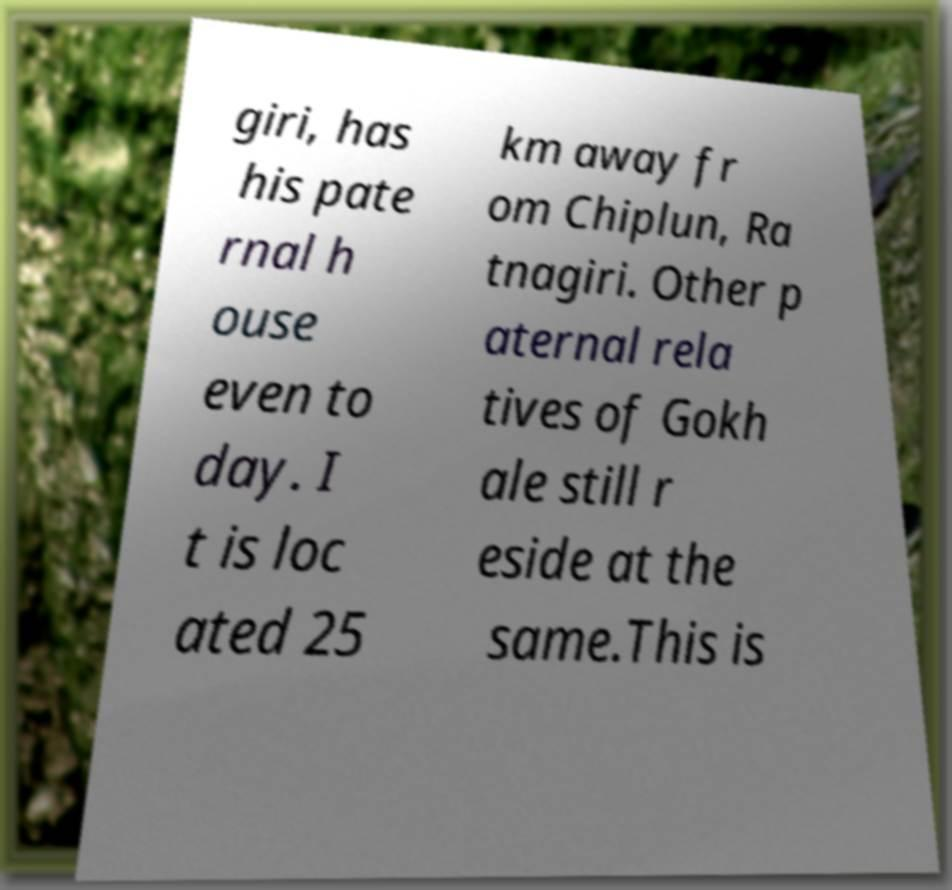Could you assist in decoding the text presented in this image and type it out clearly? giri, has his pate rnal h ouse even to day. I t is loc ated 25 km away fr om Chiplun, Ra tnagiri. Other p aternal rela tives of Gokh ale still r eside at the same.This is 